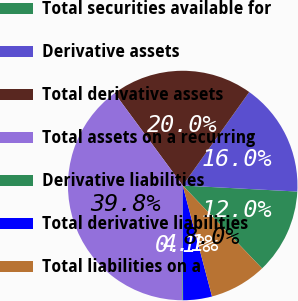<chart> <loc_0><loc_0><loc_500><loc_500><pie_chart><fcel>Total securities available for<fcel>Derivative assets<fcel>Total derivative assets<fcel>Total assets on a recurring<fcel>Derivative liabilities<fcel>Total derivative liabilities<fcel>Total liabilities on a<nl><fcel>12.01%<fcel>15.99%<fcel>19.96%<fcel>39.84%<fcel>0.09%<fcel>4.06%<fcel>8.04%<nl></chart> 